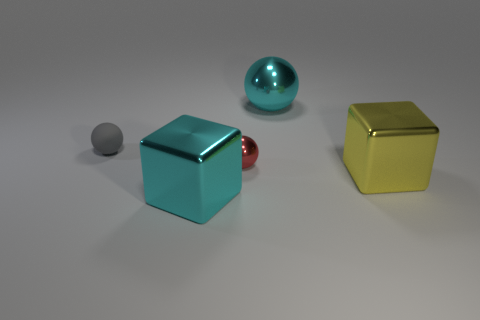What number of large metal cubes have the same color as the big sphere?
Provide a succinct answer. 1. What material is the big block that is the same color as the big sphere?
Keep it short and to the point. Metal. There is another large object that is the same shape as the gray rubber object; what material is it?
Your response must be concise. Metal. Is there a cyan metallic sphere in front of the cyan object in front of the big yellow block?
Ensure brevity in your answer.  No. Does the matte object have the same shape as the small metallic thing?
Your answer should be very brief. Yes. The tiny red thing that is the same material as the yellow cube is what shape?
Provide a succinct answer. Sphere. There is a block left of the small metallic object; is its size the same as the sphere that is in front of the small gray object?
Keep it short and to the point. No. Is the number of large blocks that are right of the red sphere greater than the number of small red metallic things that are right of the cyan metallic ball?
Provide a short and direct response. Yes. How many other objects are there of the same color as the rubber ball?
Ensure brevity in your answer.  0. There is a tiny matte object; is its color the same as the metal ball in front of the gray object?
Give a very brief answer. No. 